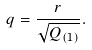Convert formula to latex. <formula><loc_0><loc_0><loc_500><loc_500>q = \frac { r } { \sqrt { Q _ { ( 1 ) } } } .</formula> 